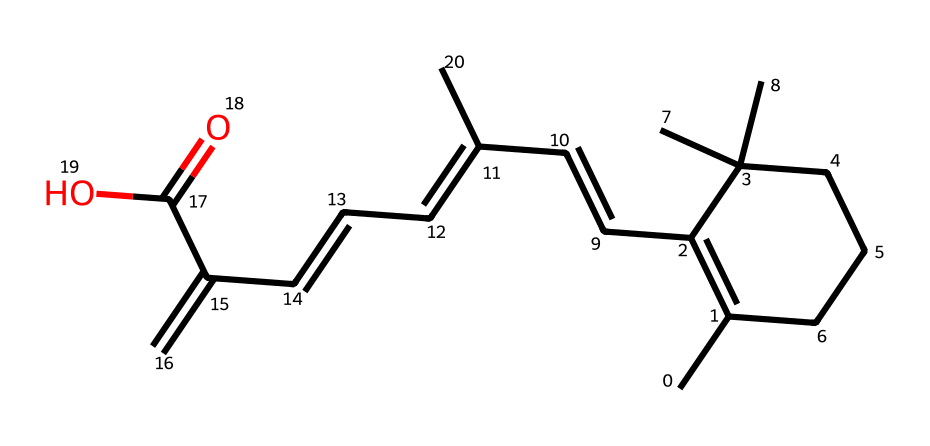What is the molecular formula of retinol? To find the molecular formula, we need to count the atoms present in the SMILES representation. The molecular formula consists of the count of carbon (C), hydrogen (H), and oxygen (O) atoms. In this case, the chemical structure shows there are 20 carbons, 30 hydrogens, and 1 oxygen.
Answer: C20H30O How many rings are in the structure of retinol? Analyzing the SMILES, we observe that the "C1=C(...C1)" notation indicates a cyclic structure. By observing the connections and the structure as a whole, we can see there is one ring present in retinol.
Answer: 1 What functional group is present in retinol? Looking at the SMILES representation, the presence of "C(=O)O" indicates the presence of a carboxylic acid functional group (due to the -COOH portion). This helps identify the functional group that contributes to the properties of retinol.
Answer: carboxylic acid How many double bonds are present in retinol? We need to evaluate the structure for double bonds, which are represented by "=" in the SMILES notation. Counting these occurrences throughout the structure, we find that there are 5 double bonds in total in retinol.
Answer: 5 What structural feature contributes to retinol's stability? Retinol features multiple carbon-carbon double bonds. These double bonds provide a degree of stability through conjugation, as they allow for resonance. The overall arrangement of bonds and the absence of highly reactive groups enhance this stability.
Answer: conjugated double bonds 